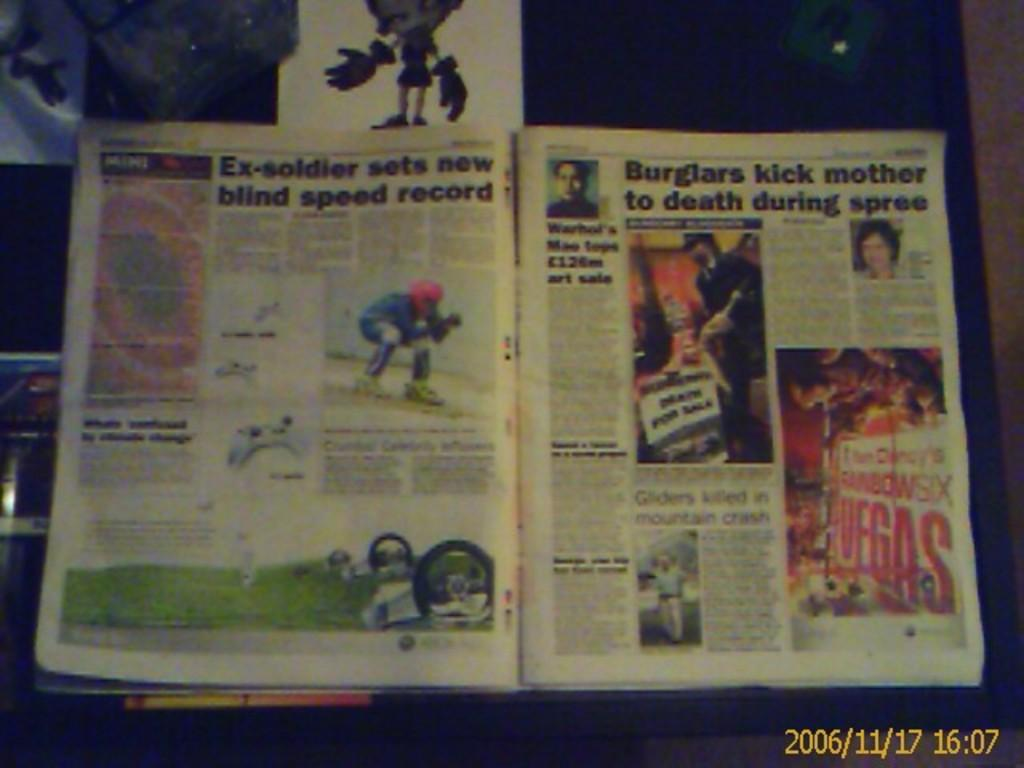<image>
Share a concise interpretation of the image provided. A newspaper that has a headline about an ex-solider setting a new record. 